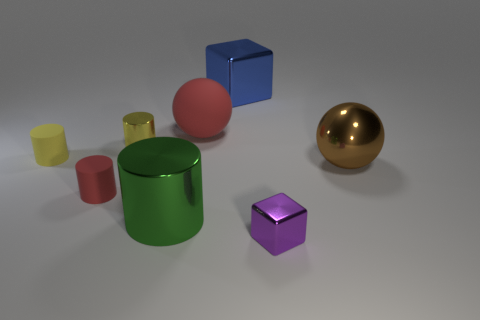There is a small rubber object that is the same color as the big matte sphere; what is its shape?
Ensure brevity in your answer.  Cylinder. There is a object that is the same color as the small metallic cylinder; what material is it?
Give a very brief answer. Rubber. Are there any purple cubes of the same size as the metallic ball?
Provide a short and direct response. No. Are there an equal number of tiny purple metal things behind the large brown shiny sphere and large metallic things that are on the right side of the big metallic block?
Your response must be concise. No. Is the material of the yellow thing in front of the yellow metal cylinder the same as the small object in front of the large green thing?
Offer a terse response. No. What is the material of the large green cylinder?
Keep it short and to the point. Metal. What number of other objects are the same color as the matte sphere?
Offer a terse response. 1. Is the color of the large rubber sphere the same as the big shiny cylinder?
Offer a terse response. No. What number of big red objects are there?
Provide a short and direct response. 1. What material is the big thing on the right side of the object behind the large rubber sphere made of?
Your answer should be compact. Metal. 